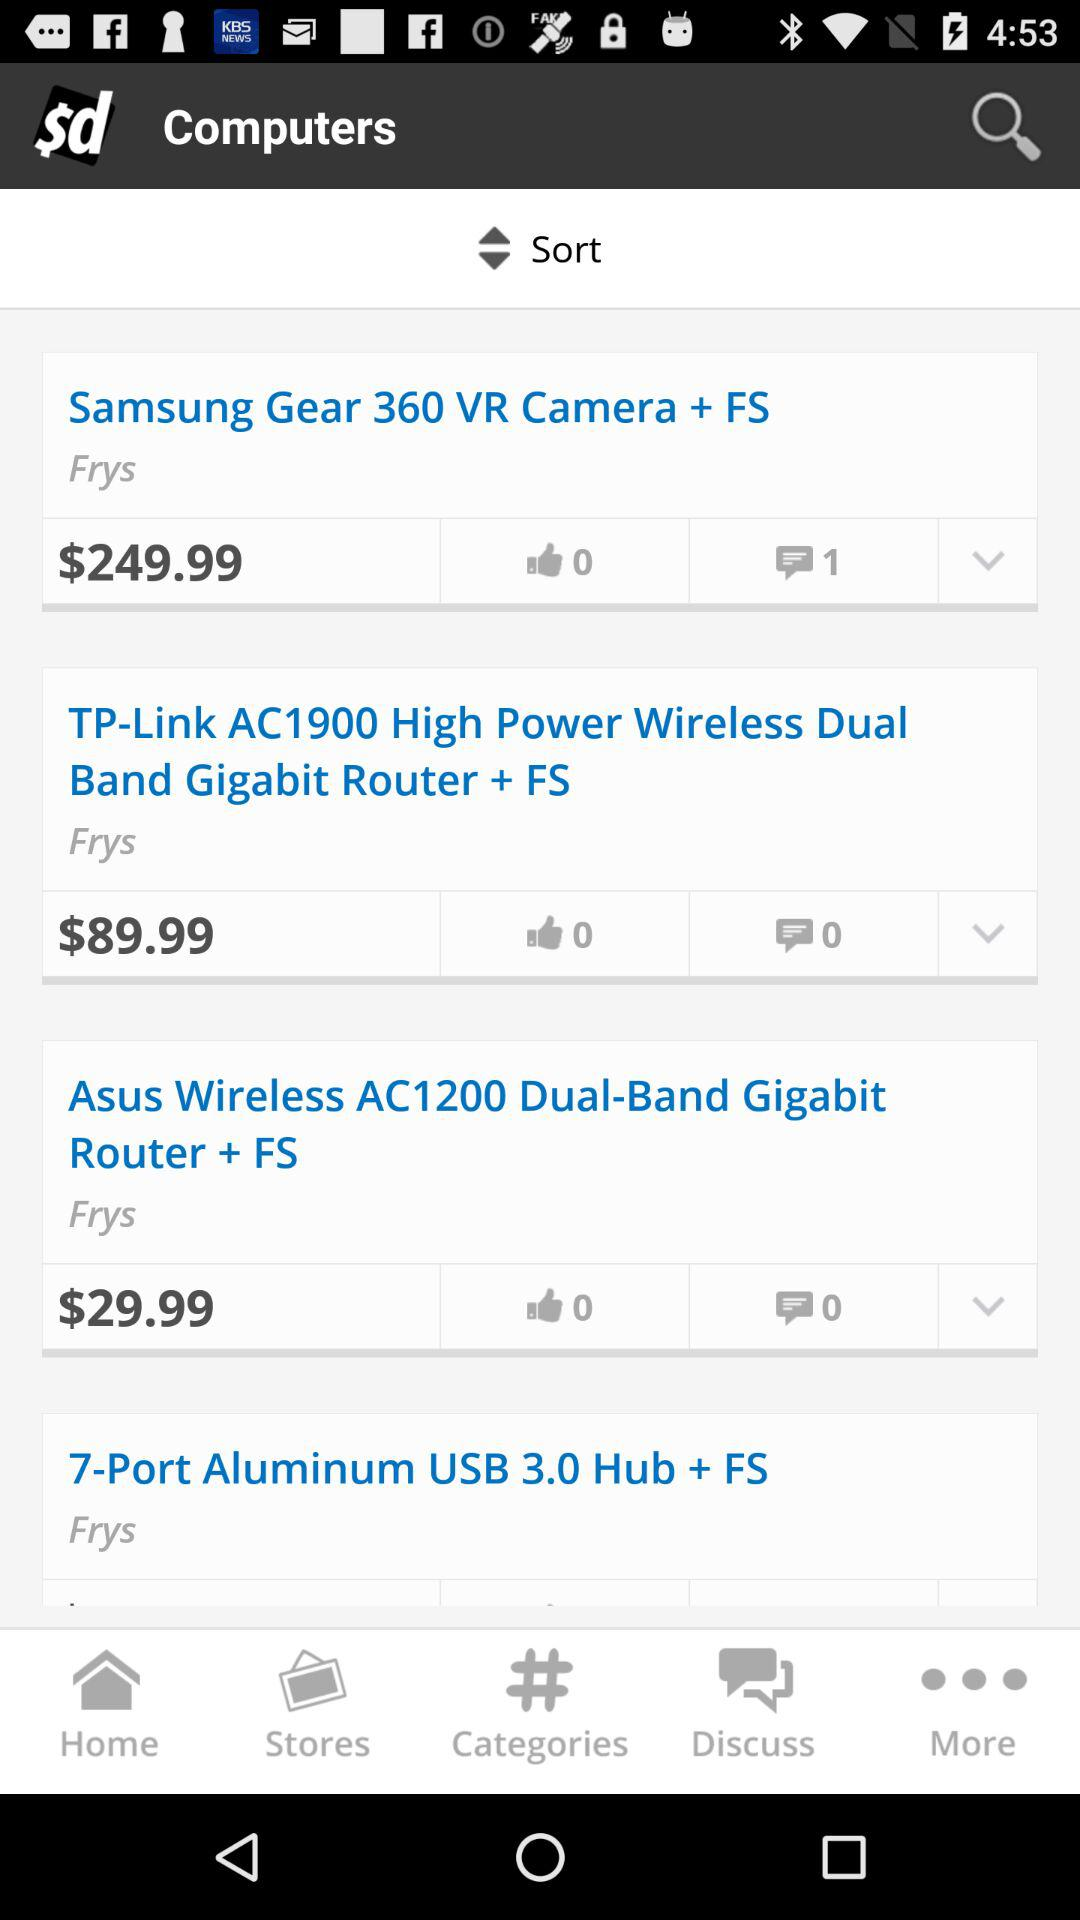How many people commented on "TP-Link AC1900"? The number of people commented on "TP-Link AC1900" is 0. 